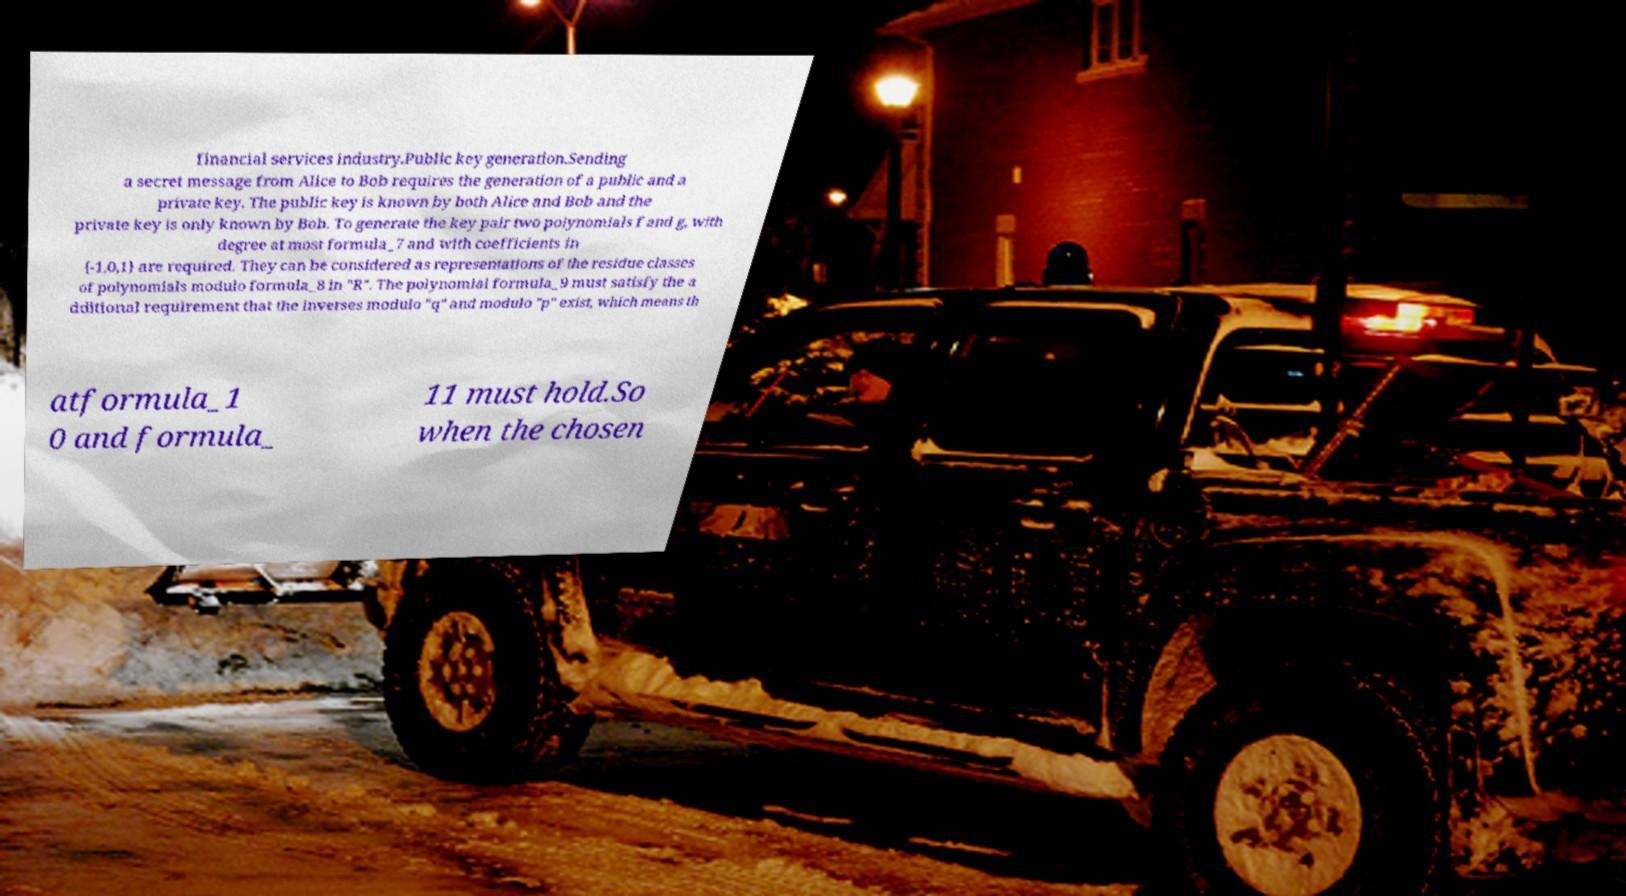Please identify and transcribe the text found in this image. financial services industry.Public key generation.Sending a secret message from Alice to Bob requires the generation of a public and a private key. The public key is known by both Alice and Bob and the private key is only known by Bob. To generate the key pair two polynomials f and g, with degree at most formula_7 and with coefficients in {-1,0,1} are required. They can be considered as representations of the residue classes of polynomials modulo formula_8 in "R". The polynomial formula_9 must satisfy the a dditional requirement that the inverses modulo "q" and modulo "p" exist, which means th atformula_1 0 and formula_ 11 must hold.So when the chosen 